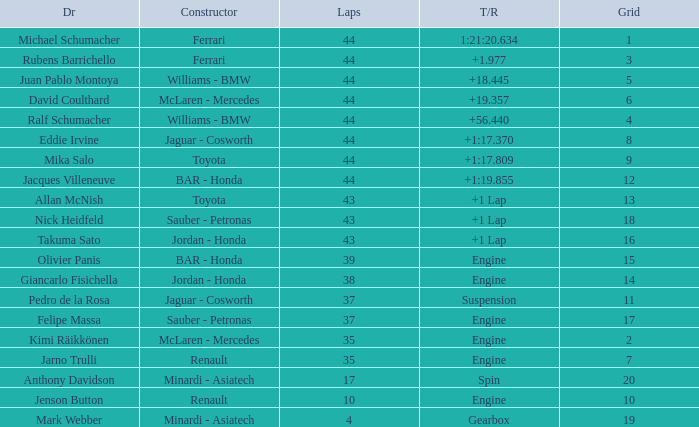What was the time of the driver on grid 3? 1.977. 